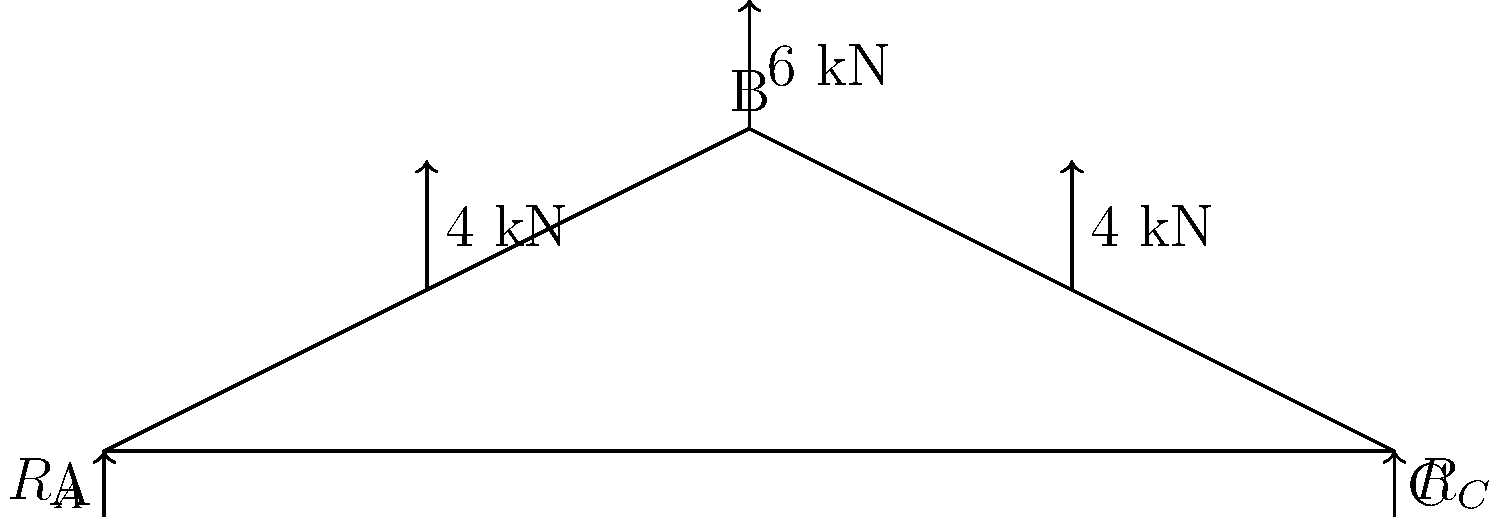As a pastor overseeing the renovation of your church in Shreveport, you're discussing the roof truss design with the engineer. The diagram shows a simple truss with three loads: a 6 kN load at the peak and two 4 kN loads on either side. What is the magnitude of the reaction force at support A ($R_A$)? To find the reaction force at support A, we'll use the principle of moments and equilibrium equations. Let's approach this step-by-step:

1) First, let's sum the vertical forces to ensure equilibrium:
   $$R_A + R_C = 6 + 4 + 4 = 14 \text{ kN}$$

2) Now, let's take moments about point C (clockwise positive):
   $$R_A \cdot 200 - 4 \cdot 150 - 6 \cdot 100 - 4 \cdot 50 = 0$$

3) Simplify the equation:
   $$200R_A - 600 - 600 - 200 = 0$$
   $$200R_A = 1400$$

4) Solve for $R_A$:
   $$R_A = \frac{1400}{200} = 7 \text{ kN}$$

5) We can verify this by calculating $R_C$:
   $$R_C = 14 - 7 = 7 \text{ kN}$$

6) Check: The sum of moments about A should be zero:
   $$7 \cdot 200 - 4 \cdot 150 - 6 \cdot 100 - 4 \cdot 50 = 0$$
   $$1400 - 600 - 600 - 200 = 0$$

Thus, the reaction force at support A ($R_A$) is 7 kN.
Answer: 7 kN 